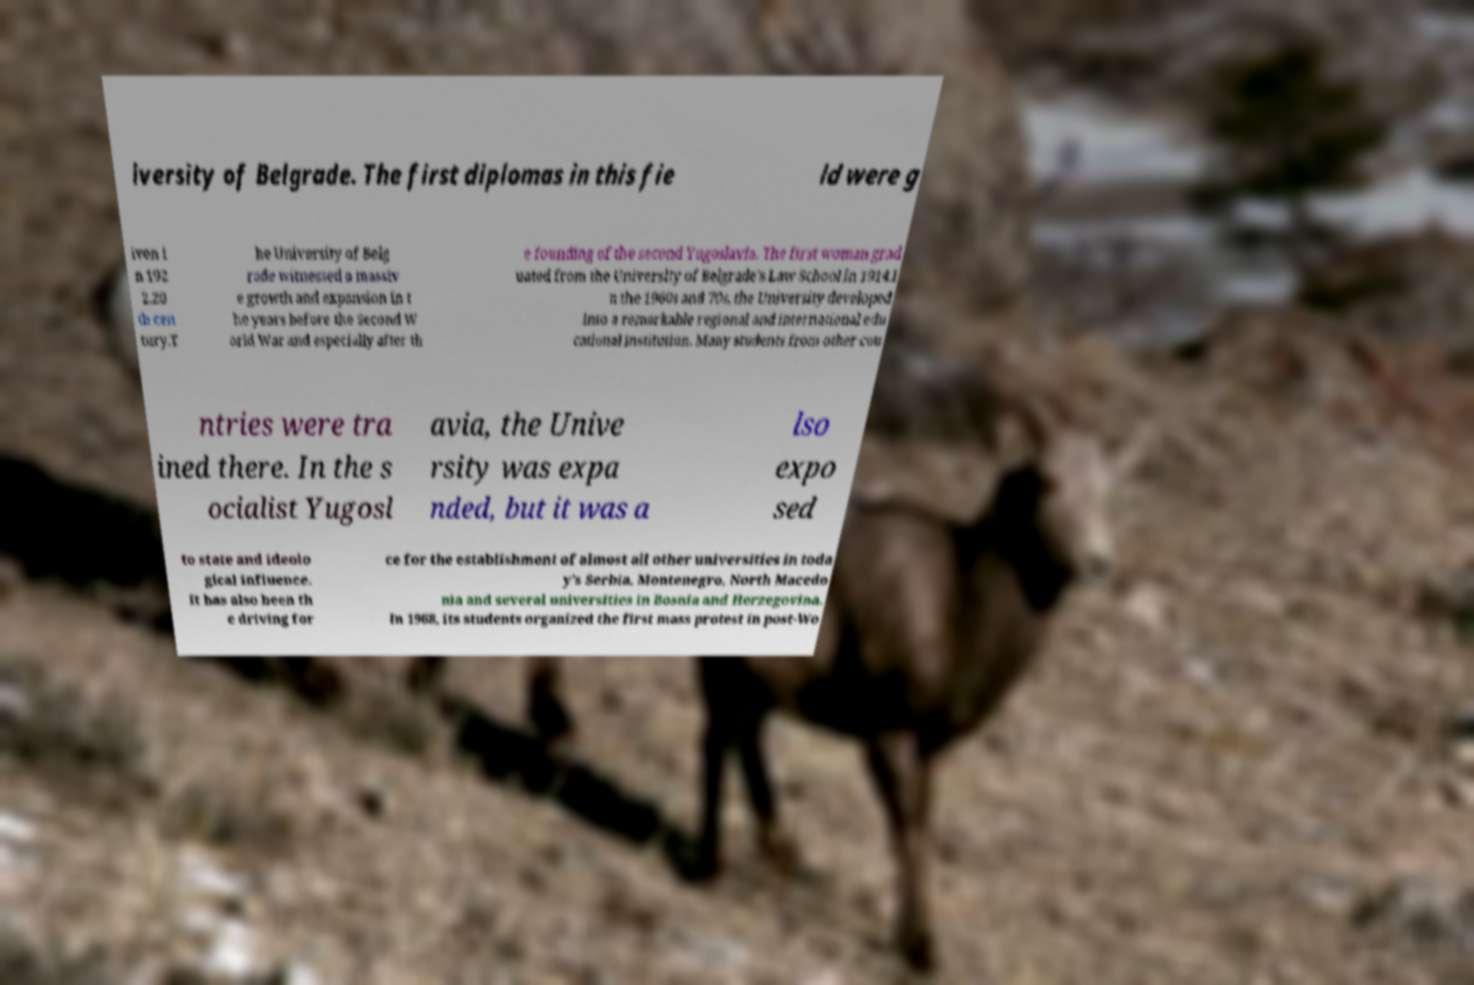I need the written content from this picture converted into text. Can you do that? iversity of Belgrade. The first diplomas in this fie ld were g iven i n 192 2.20 th cen tury.T he University of Belg rade witnessed a massiv e growth and expansion in t he years before the Second W orld War and especially after th e founding of the second Yugoslavia. The first woman grad uated from the University of Belgrade's Law School in 1914.I n the 1960s and 70s, the University developed into a remarkable regional and international edu cational institution. Many students from other cou ntries were tra ined there. In the s ocialist Yugosl avia, the Unive rsity was expa nded, but it was a lso expo sed to state and ideolo gical influence. It has also been th e driving for ce for the establishment of almost all other universities in toda y's Serbia, Montenegro, North Macedo nia and several universities in Bosnia and Herzegovina. In 1968, its students organized the first mass protest in post-Wo 